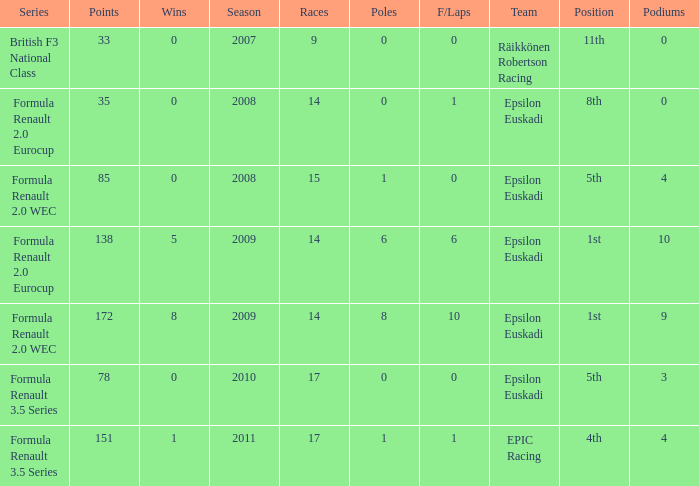How many podiums when he was in the british f3 national class series? 1.0. 